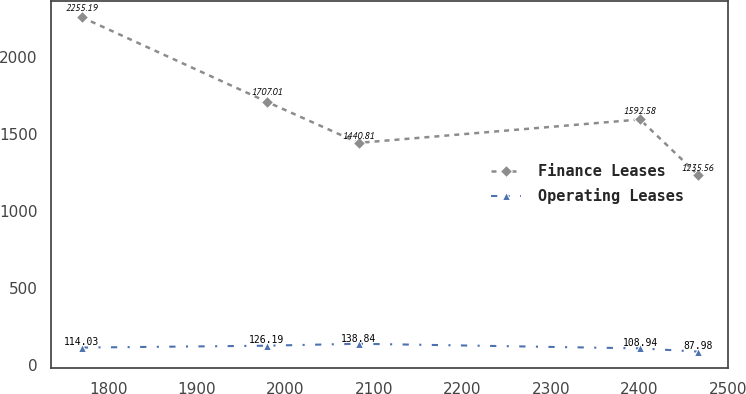<chart> <loc_0><loc_0><loc_500><loc_500><line_chart><ecel><fcel>Finance Leases<fcel>Operating Leases<nl><fcel>1769.94<fcel>2255.19<fcel>114.03<nl><fcel>1979.02<fcel>1707.01<fcel>126.19<nl><fcel>2082.67<fcel>1440.81<fcel>138.84<nl><fcel>2400.69<fcel>1592.58<fcel>108.94<nl><fcel>2465.79<fcel>1235.56<fcel>87.98<nl></chart> 